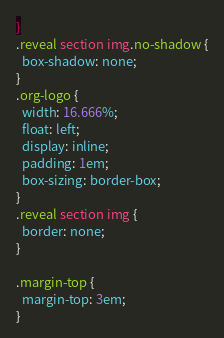<code> <loc_0><loc_0><loc_500><loc_500><_CSS_>}
.reveal section img.no-shadow {
  box-shadow: none;
}
.org-logo {
  width: 16.666%;
  float: left;
  display: inline;
  padding: 1em;
  box-sizing: border-box;
}
.reveal section img {
  border: none;
}

.margin-top {
  margin-top: 3em;
}</code> 